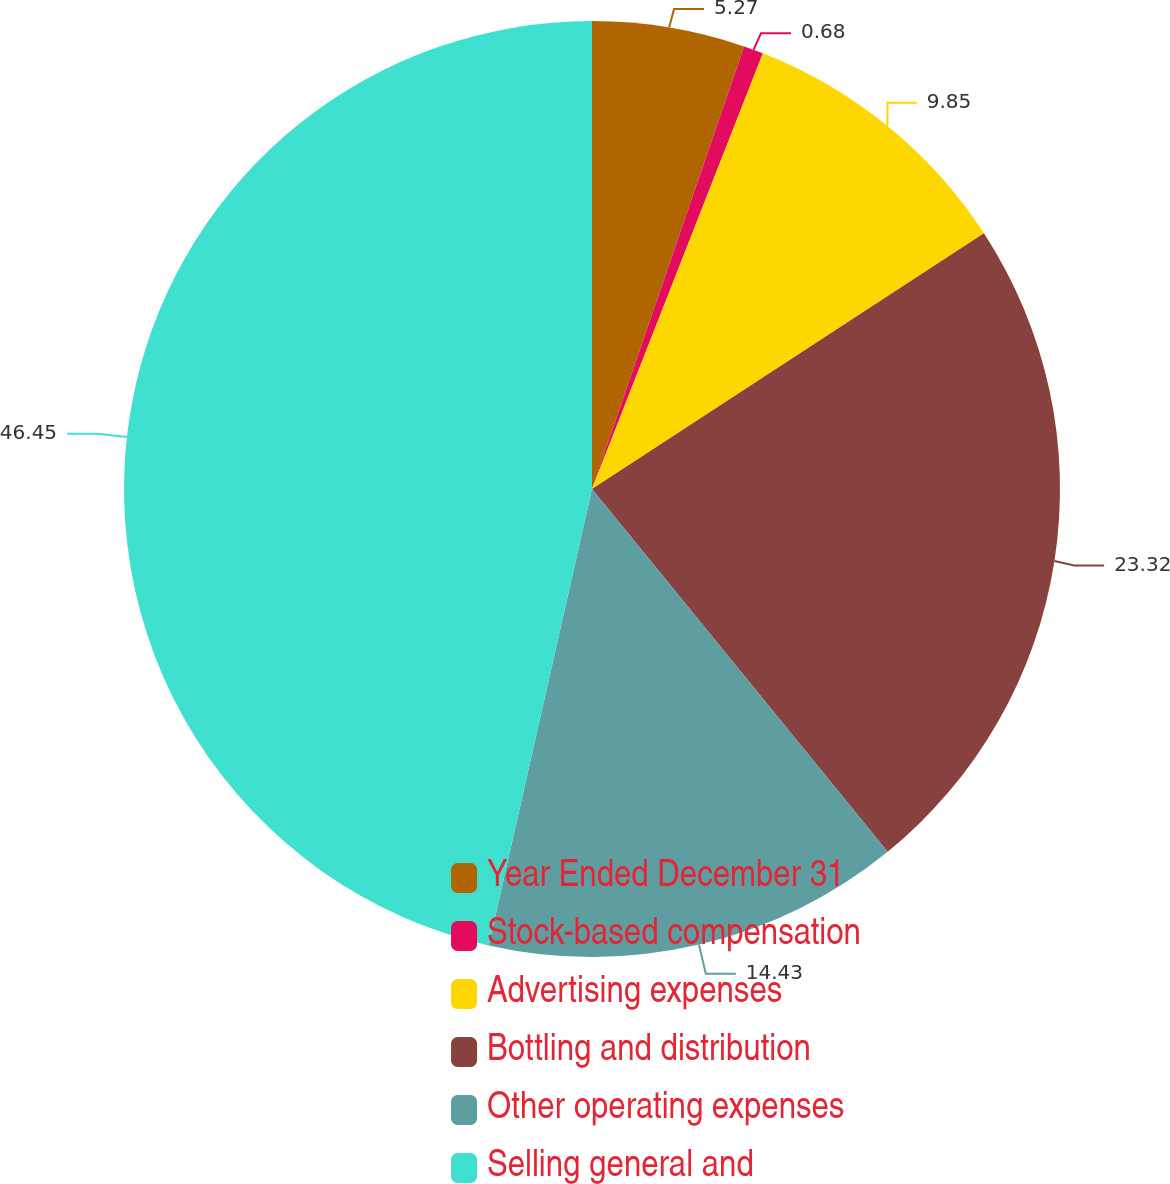Convert chart to OTSL. <chart><loc_0><loc_0><loc_500><loc_500><pie_chart><fcel>Year Ended December 31<fcel>Stock-based compensation<fcel>Advertising expenses<fcel>Bottling and distribution<fcel>Other operating expenses<fcel>Selling general and<nl><fcel>5.27%<fcel>0.68%<fcel>9.85%<fcel>23.32%<fcel>14.43%<fcel>46.46%<nl></chart> 